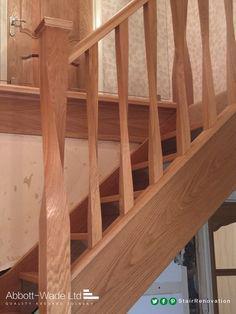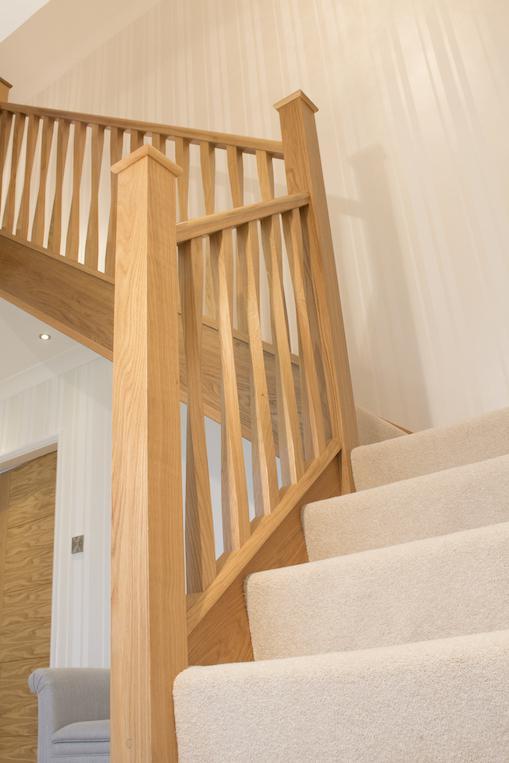The first image is the image on the left, the second image is the image on the right. For the images shown, is this caption "In one of the images, the stairway post is made of wood and metal." true? Answer yes or no. No. The first image is the image on the left, the second image is the image on the right. Analyze the images presented: Is the assertion "One image shows a wooden stair baluster with a silver cap, and vertical rails of twisted wood in front of gray carpeting." valid? Answer yes or no. No. 